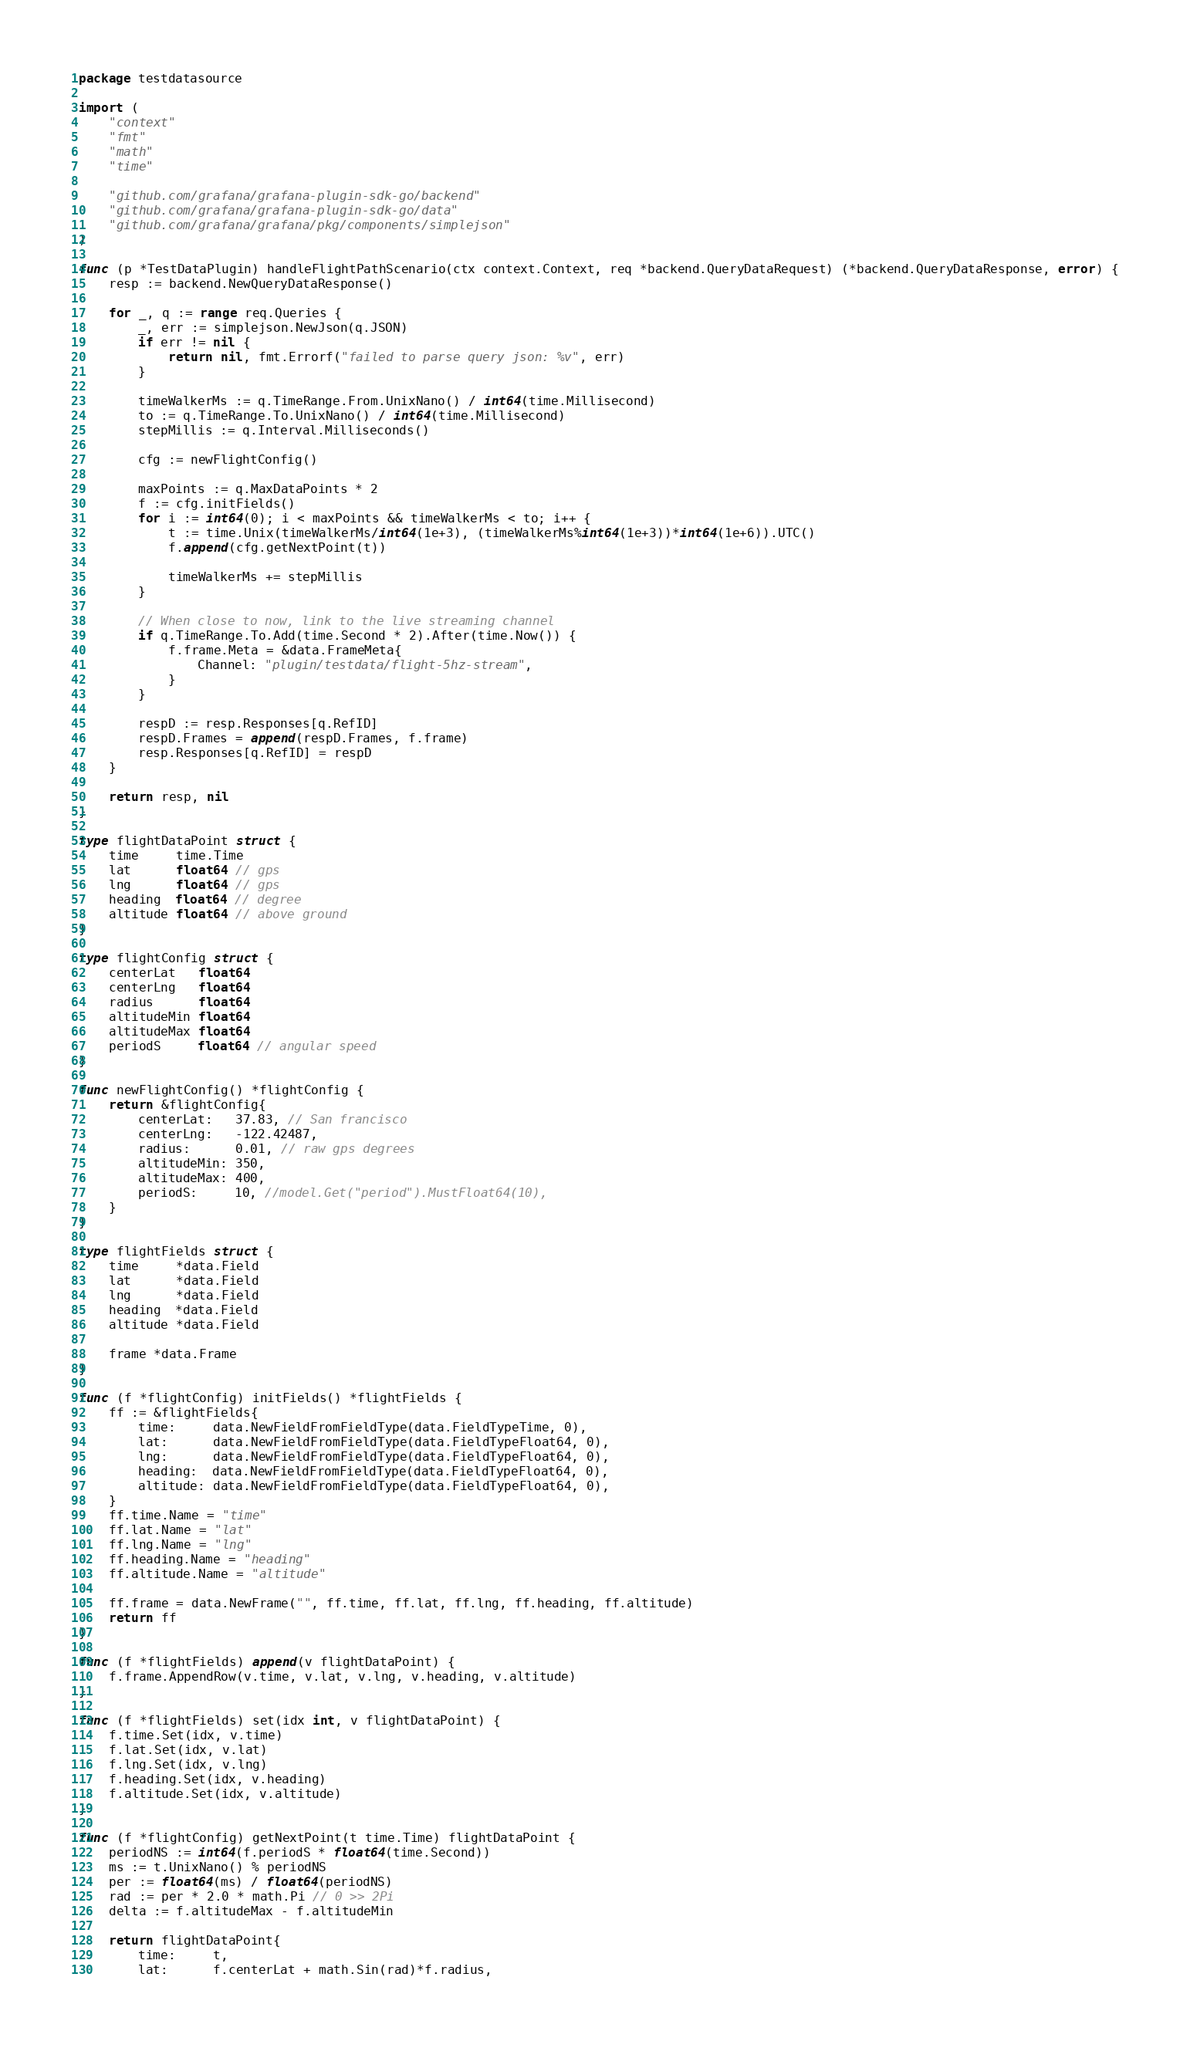Convert code to text. <code><loc_0><loc_0><loc_500><loc_500><_Go_>package testdatasource

import (
	"context"
	"fmt"
	"math"
	"time"

	"github.com/grafana/grafana-plugin-sdk-go/backend"
	"github.com/grafana/grafana-plugin-sdk-go/data"
	"github.com/grafana/grafana/pkg/components/simplejson"
)

func (p *TestDataPlugin) handleFlightPathScenario(ctx context.Context, req *backend.QueryDataRequest) (*backend.QueryDataResponse, error) {
	resp := backend.NewQueryDataResponse()

	for _, q := range req.Queries {
		_, err := simplejson.NewJson(q.JSON)
		if err != nil {
			return nil, fmt.Errorf("failed to parse query json: %v", err)
		}

		timeWalkerMs := q.TimeRange.From.UnixNano() / int64(time.Millisecond)
		to := q.TimeRange.To.UnixNano() / int64(time.Millisecond)
		stepMillis := q.Interval.Milliseconds()

		cfg := newFlightConfig()

		maxPoints := q.MaxDataPoints * 2
		f := cfg.initFields()
		for i := int64(0); i < maxPoints && timeWalkerMs < to; i++ {
			t := time.Unix(timeWalkerMs/int64(1e+3), (timeWalkerMs%int64(1e+3))*int64(1e+6)).UTC()
			f.append(cfg.getNextPoint(t))

			timeWalkerMs += stepMillis
		}

		// When close to now, link to the live streaming channel
		if q.TimeRange.To.Add(time.Second * 2).After(time.Now()) {
			f.frame.Meta = &data.FrameMeta{
				Channel: "plugin/testdata/flight-5hz-stream",
			}
		}

		respD := resp.Responses[q.RefID]
		respD.Frames = append(respD.Frames, f.frame)
		resp.Responses[q.RefID] = respD
	}

	return resp, nil
}

type flightDataPoint struct {
	time     time.Time
	lat      float64 // gps
	lng      float64 // gps
	heading  float64 // degree
	altitude float64 // above ground
}

type flightConfig struct {
	centerLat   float64
	centerLng   float64
	radius      float64
	altitudeMin float64
	altitudeMax float64
	periodS     float64 // angular speed
}

func newFlightConfig() *flightConfig {
	return &flightConfig{
		centerLat:   37.83, // San francisco
		centerLng:   -122.42487,
		radius:      0.01, // raw gps degrees
		altitudeMin: 350,
		altitudeMax: 400,
		periodS:     10, //model.Get("period").MustFloat64(10),
	}
}

type flightFields struct {
	time     *data.Field
	lat      *data.Field
	lng      *data.Field
	heading  *data.Field
	altitude *data.Field

	frame *data.Frame
}

func (f *flightConfig) initFields() *flightFields {
	ff := &flightFields{
		time:     data.NewFieldFromFieldType(data.FieldTypeTime, 0),
		lat:      data.NewFieldFromFieldType(data.FieldTypeFloat64, 0),
		lng:      data.NewFieldFromFieldType(data.FieldTypeFloat64, 0),
		heading:  data.NewFieldFromFieldType(data.FieldTypeFloat64, 0),
		altitude: data.NewFieldFromFieldType(data.FieldTypeFloat64, 0),
	}
	ff.time.Name = "time"
	ff.lat.Name = "lat"
	ff.lng.Name = "lng"
	ff.heading.Name = "heading"
	ff.altitude.Name = "altitude"

	ff.frame = data.NewFrame("", ff.time, ff.lat, ff.lng, ff.heading, ff.altitude)
	return ff
}

func (f *flightFields) append(v flightDataPoint) {
	f.frame.AppendRow(v.time, v.lat, v.lng, v.heading, v.altitude)
}

func (f *flightFields) set(idx int, v flightDataPoint) {
	f.time.Set(idx, v.time)
	f.lat.Set(idx, v.lat)
	f.lng.Set(idx, v.lng)
	f.heading.Set(idx, v.heading)
	f.altitude.Set(idx, v.altitude)
}

func (f *flightConfig) getNextPoint(t time.Time) flightDataPoint {
	periodNS := int64(f.periodS * float64(time.Second))
	ms := t.UnixNano() % periodNS
	per := float64(ms) / float64(periodNS)
	rad := per * 2.0 * math.Pi // 0 >> 2Pi
	delta := f.altitudeMax - f.altitudeMin

	return flightDataPoint{
		time:     t,
		lat:      f.centerLat + math.Sin(rad)*f.radius,</code> 